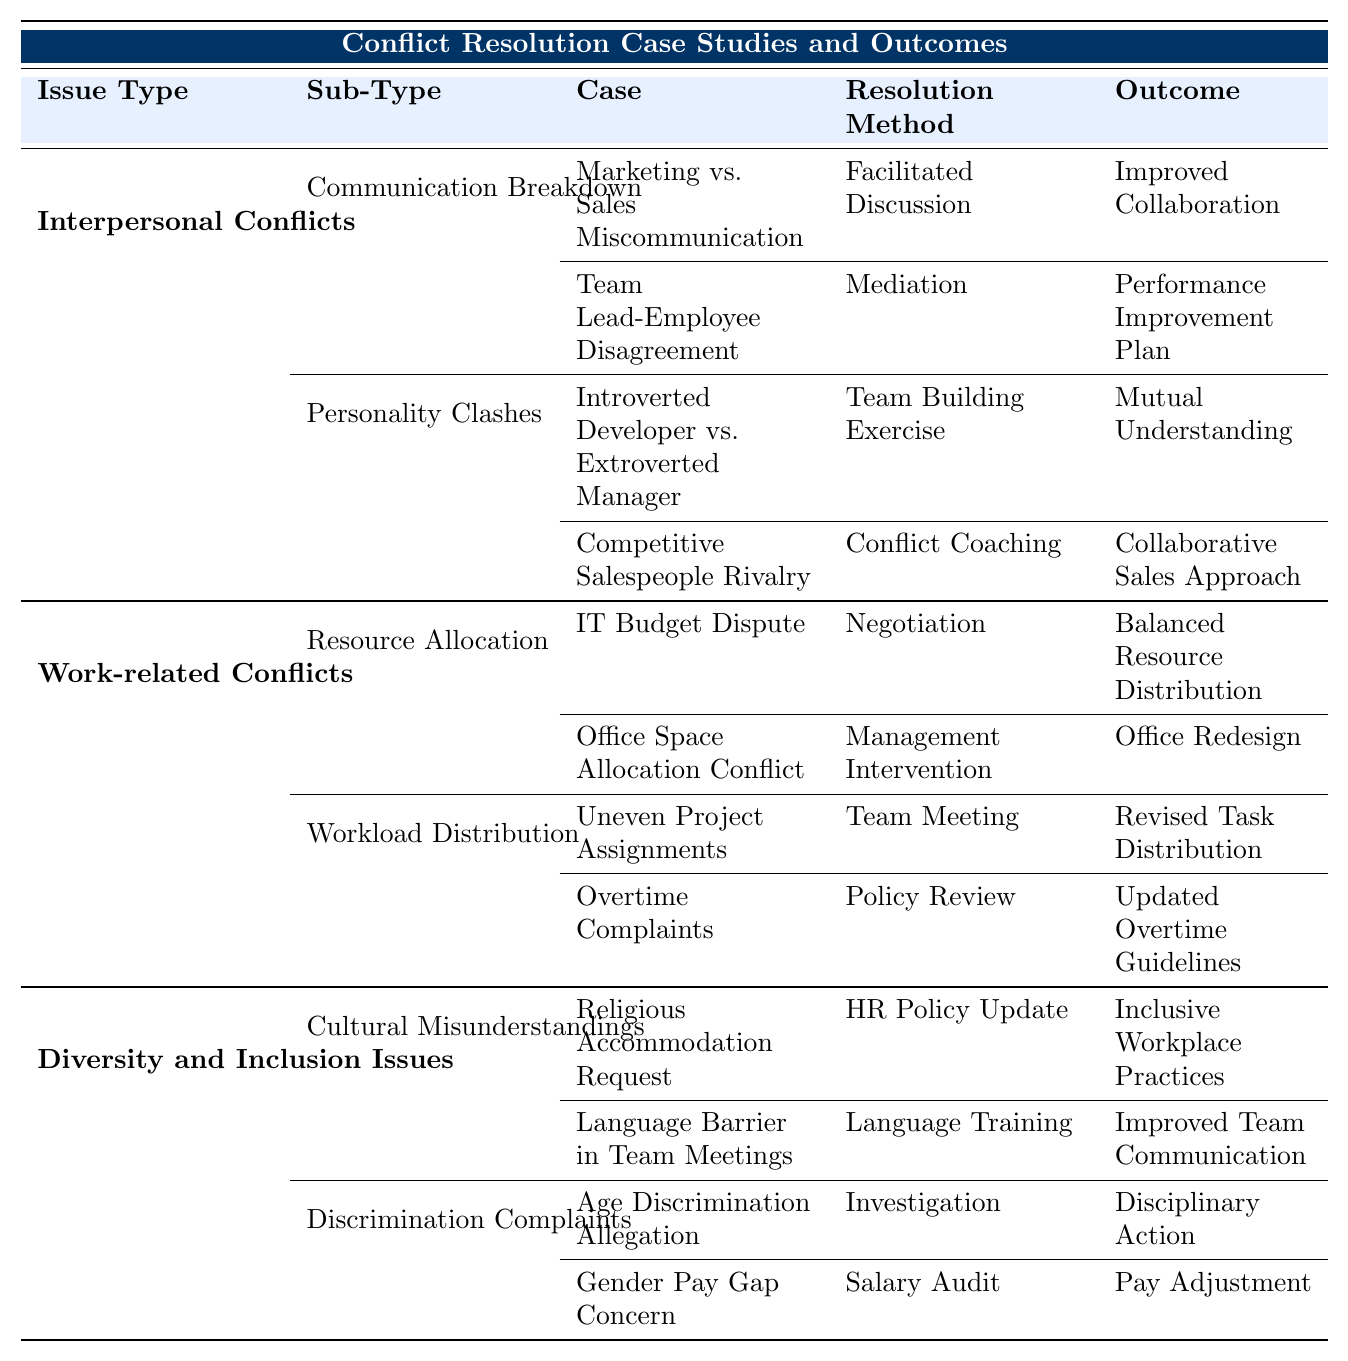What is the resolution method used for the case "IT Budget Dispute"? The table states that the resolution method for the "IT Budget Dispute" case is "Negotiation".
Answer: Negotiation How long did it take to resolve the "Overtime Complaints" case? According to the table, the time to resolve the "Overtime Complaints" case is "3 weeks".
Answer: 3 weeks Which conflict type took the longest to resolve, and what was the issue? From the table, the conflict that took the longest to resolve is "Language Barrier in Team Meetings," which took "3 months".
Answer: Language Barrier in Team Meetings How many cases were resolved with a "Team Meeting" method? There are two cases with the "Team Meeting" method: "Uneven Project Assignments" and "Overtime Complaints".
Answer: 2 What was the outcome of the "Competitive Salespeople Rivalry" case? The outcome listed in the table for the "Competitive Salespeople Rivalry" case is "Collaborative Sales Approach".
Answer: Collaborative Sales Approach Is there any case related to discrimination that resulted in disciplinary action? Yes, the "Age Discrimination Allegation" case resulted in "Disciplinary Action".
Answer: Yes What are the resolution methods used for interpersonal conflicts? The resolution methods for interpersonal conflicts listed are "Facilitated Discussion," "Mediation," "Team Building Exercise," and "Conflict Coaching".
Answer: Facilitated Discussion, Mediation, Team Building Exercise, Conflict Coaching What percentage of the cases in the "Diversity and Inclusion Issues" category resolved in less than 2 months? In the "Diversity and Inclusion Issues" category, 2 out of 4 cases resolved in less than 2 months (i.e., "Religious Accommodation Request" and "Age Discrimination Allegation"), which is 50%.
Answer: 50% Among the cases in "Cultural Misunderstandings," which one had the longest time to resolve? The case "Language Barrier in Team Meetings" had the longest time to resolve at "3 months".
Answer: Language Barrier in Team Meetings What was a common outcome for both cases under "Workload Distribution"? The common outcome for both cases under "Workload Distribution" was updates to task distribution processes and guidelines.
Answer: Updates to task distribution processes and guidelines 